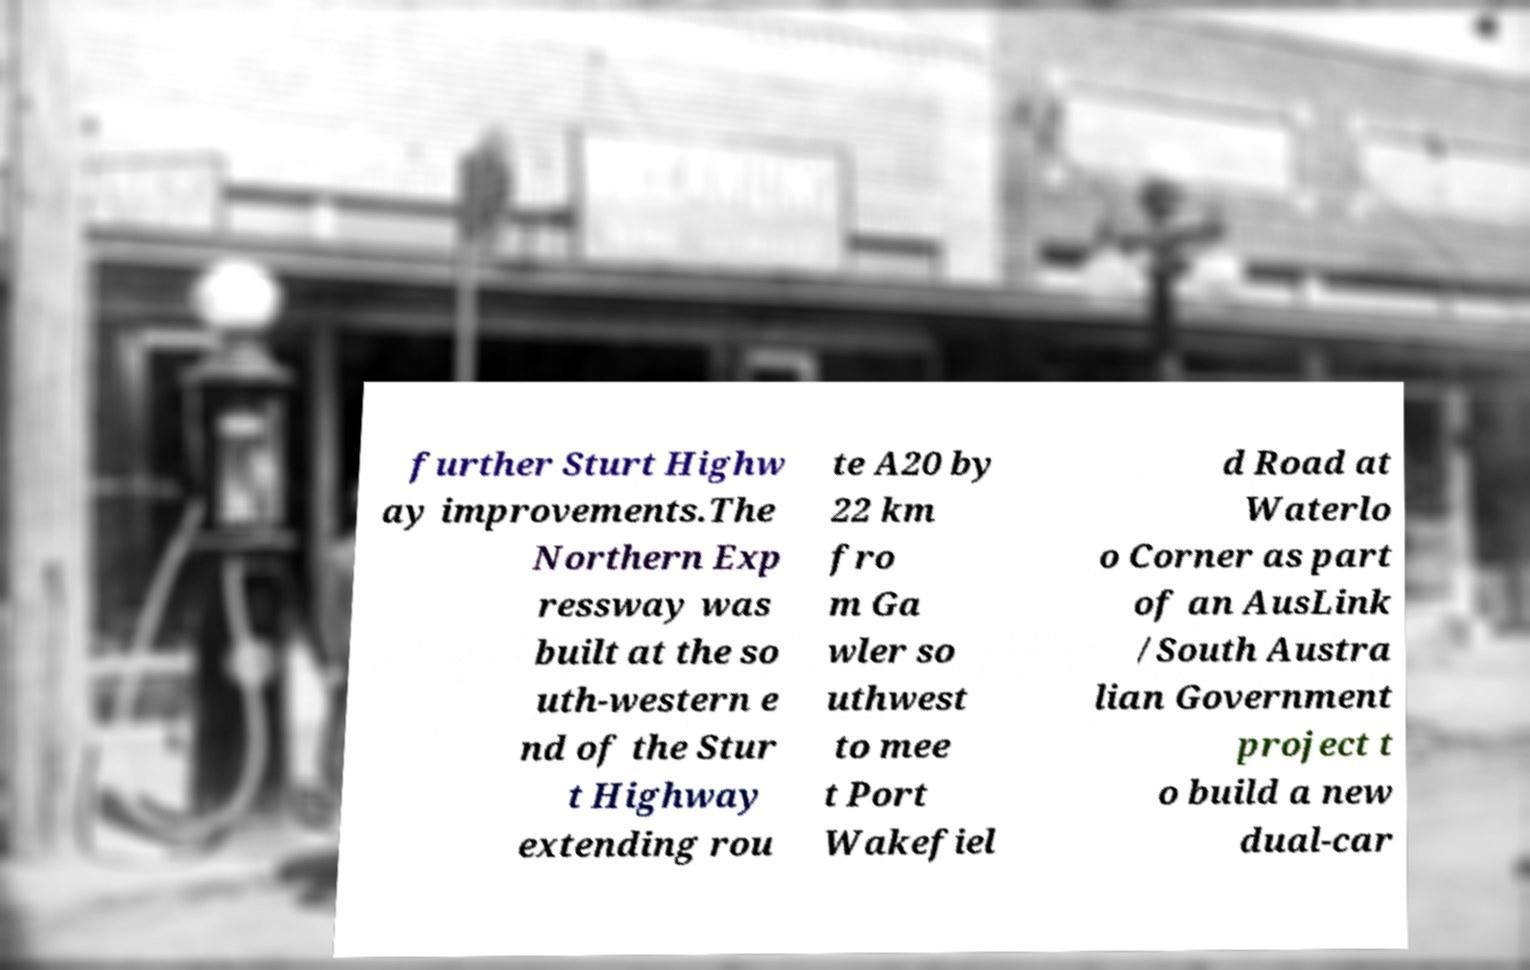For documentation purposes, I need the text within this image transcribed. Could you provide that? further Sturt Highw ay improvements.The Northern Exp ressway was built at the so uth-western e nd of the Stur t Highway extending rou te A20 by 22 km fro m Ga wler so uthwest to mee t Port Wakefiel d Road at Waterlo o Corner as part of an AusLink /South Austra lian Government project t o build a new dual-car 